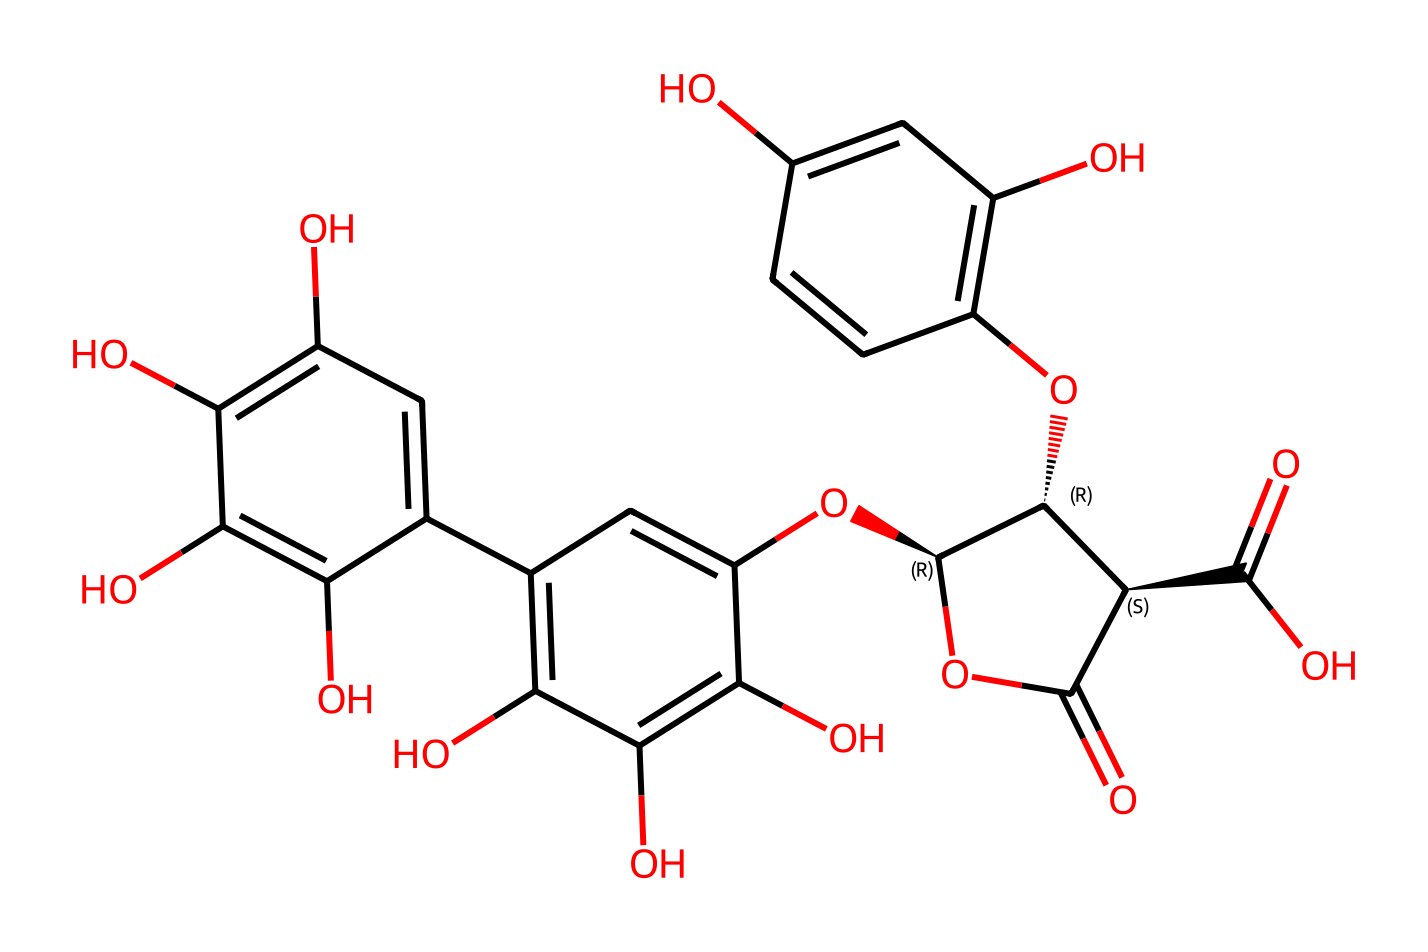What is the main functional group present in this chemical? The structure contains multiple hydroxyl (-OH) groups, which are characteristic of phenolic compounds and indicate the presence of alcohol. These hydroxyl groups contribute to the chemical's ability to bind and react with other substances.
Answer: hydroxyl group How many aromatic rings are there in the chemical structure? By examining the structure, there are four distinct aromatic rings present in the overall chemical framework, comprising alternating double bonds. This indicates a rich aromatic nature typical of tannins.
Answer: four What type of chemical compounds are represented by this structure? The chemical structure is recognized as a polyphenol due to its multiple phenolic hydroxyl groups, which classify it within the tannin family, widely known for their tannic properties, especially in leather treatments.
Answer: polyphenol What is the total number of oxygen atoms in this structure? Counting the oxygen atoms in the representation shows a total of 14 oxygen atoms present in various functional groups including hydroxyl and ether linkages. This highlights the oxygen saturation common in tannins.
Answer: fourteen Which property does the presence of multiple hydroxyl groups in this compound suggest? The multiple hydroxyl groups are indicative of strong hydrogen bonding capabilities, which can enhance water solubility and interaction with various materials, making this compound effective in leather conditioning treatments.
Answer: water solubility 